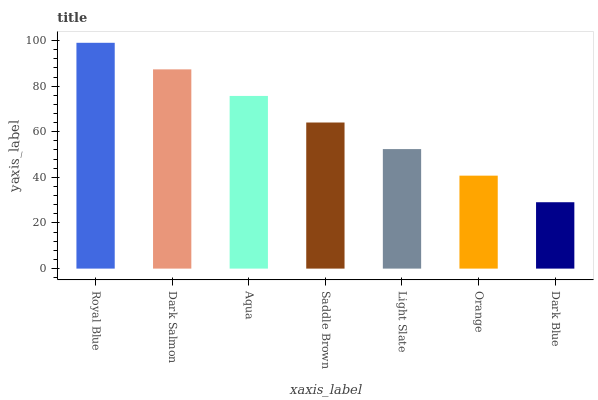Is Dark Blue the minimum?
Answer yes or no. Yes. Is Royal Blue the maximum?
Answer yes or no. Yes. Is Dark Salmon the minimum?
Answer yes or no. No. Is Dark Salmon the maximum?
Answer yes or no. No. Is Royal Blue greater than Dark Salmon?
Answer yes or no. Yes. Is Dark Salmon less than Royal Blue?
Answer yes or no. Yes. Is Dark Salmon greater than Royal Blue?
Answer yes or no. No. Is Royal Blue less than Dark Salmon?
Answer yes or no. No. Is Saddle Brown the high median?
Answer yes or no. Yes. Is Saddle Brown the low median?
Answer yes or no. Yes. Is Dark Blue the high median?
Answer yes or no. No. Is Orange the low median?
Answer yes or no. No. 